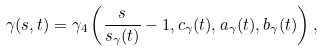Convert formula to latex. <formula><loc_0><loc_0><loc_500><loc_500>\gamma ( s , t ) = \gamma _ { 4 } \left ( \frac { s } { s _ { \gamma } ( t ) } - 1 , c _ { \gamma } ( t ) , a _ { \gamma } ( t ) , b _ { \gamma } ( t ) \right ) ,</formula> 